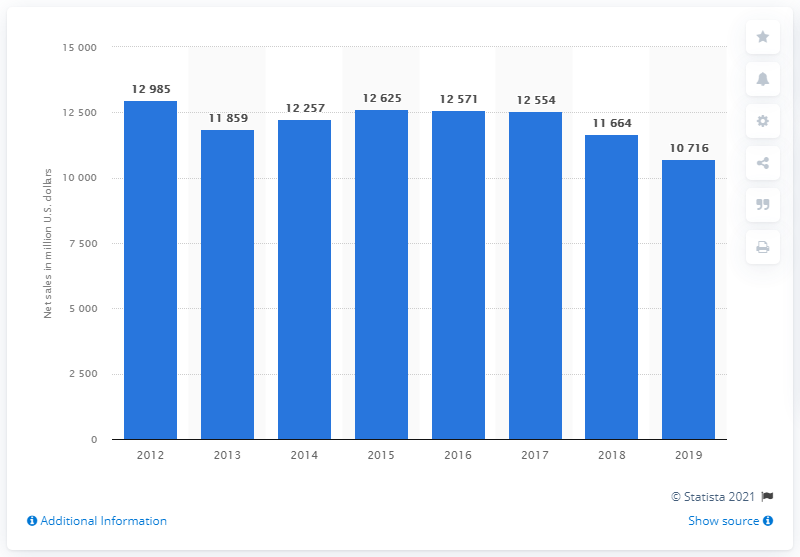Mention a couple of crucial points in this snapshot. J.C. Penney's net sales in 2019 were 10,716. 